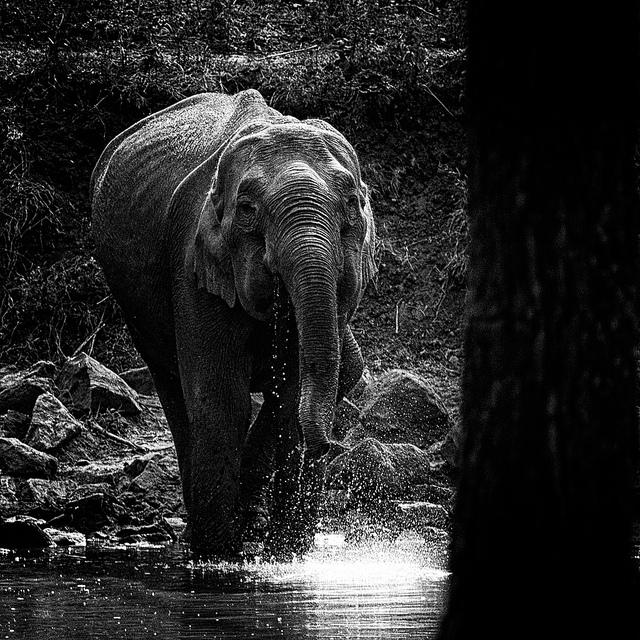Where is the elephant in this photo?
Answer briefly. Water. Where is the elephant looking at?
Answer briefly. Camera. Is the elephant in water?
Keep it brief. Yes. 